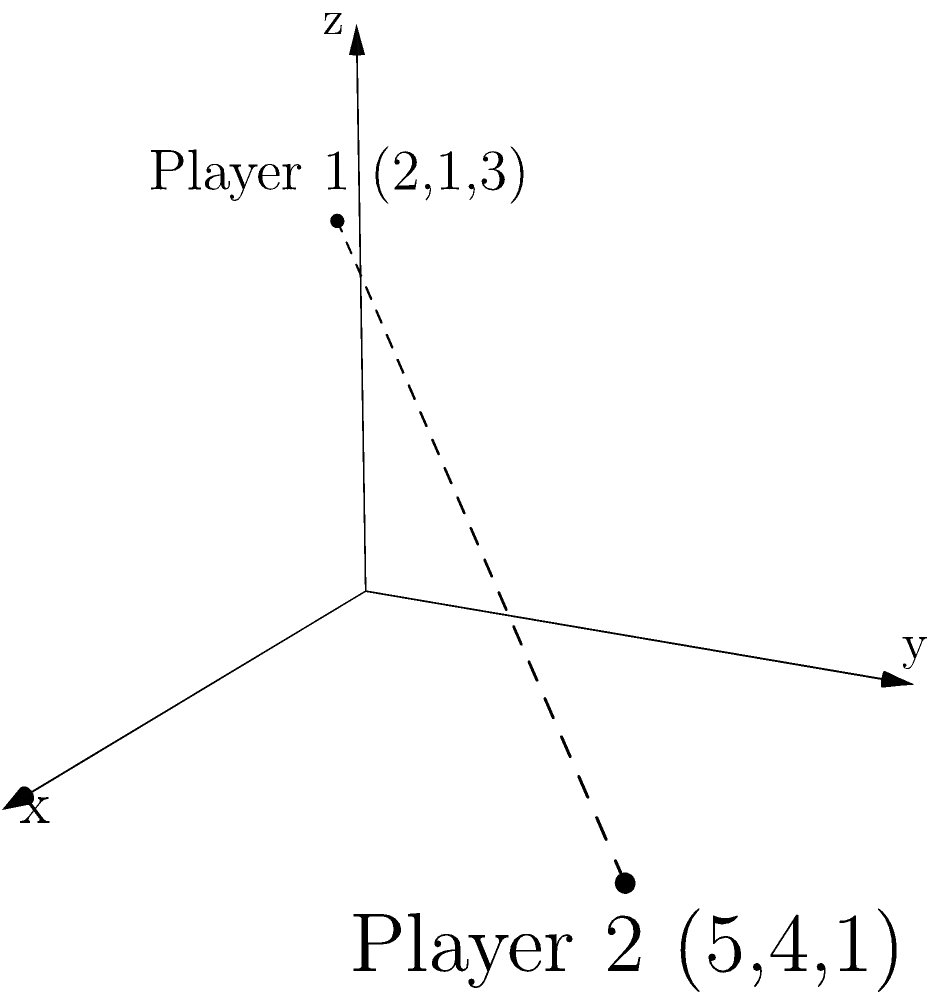In a 3D game world, Player 1 is located at coordinates (2, 1, 3) and Player 2 is at (5, 4, 1). Calculate the straight-line distance between these two players to determine if they're within the game's interaction range of 5 units. To solve this problem, we'll use the 3D distance formula, which is an extension of the Pythagorean theorem:

1) The 3D distance formula is:
   $$d = \sqrt{(x_2-x_1)^2 + (y_2-y_1)^2 + (z_2-z_1)^2}$$

2) Let's identify our coordinates:
   Player 1: $(x_1, y_1, z_1) = (2, 1, 3)$
   Player 2: $(x_2, y_2, z_2) = (5, 4, 1)$

3) Now, let's substitute these into our formula:
   $$d = \sqrt{(5-2)^2 + (4-1)^2 + (1-3)^2}$$

4) Simplify inside the parentheses:
   $$d = \sqrt{3^2 + 3^2 + (-2)^2}$$

5) Calculate the squares:
   $$d = \sqrt{9 + 9 + 4}$$

6) Add inside the square root:
   $$d = \sqrt{22}$$

7) Simplify:
   $$d \approx 4.69$$

8) Since 4.69 is less than 5, the players are within the interaction range.
Answer: $\sqrt{22}$ units or approximately 4.69 units 